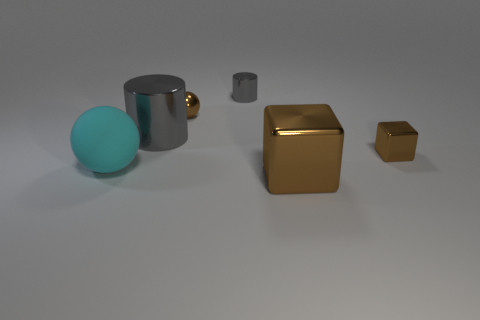Subtract all cyan balls. Subtract all gray cubes. How many balls are left? 1 Add 1 large spheres. How many objects exist? 7 Subtract all cylinders. How many objects are left? 4 Subtract all large cubes. Subtract all large brown blocks. How many objects are left? 4 Add 6 small blocks. How many small blocks are left? 7 Add 6 brown metal balls. How many brown metal balls exist? 7 Subtract 0 yellow spheres. How many objects are left? 6 